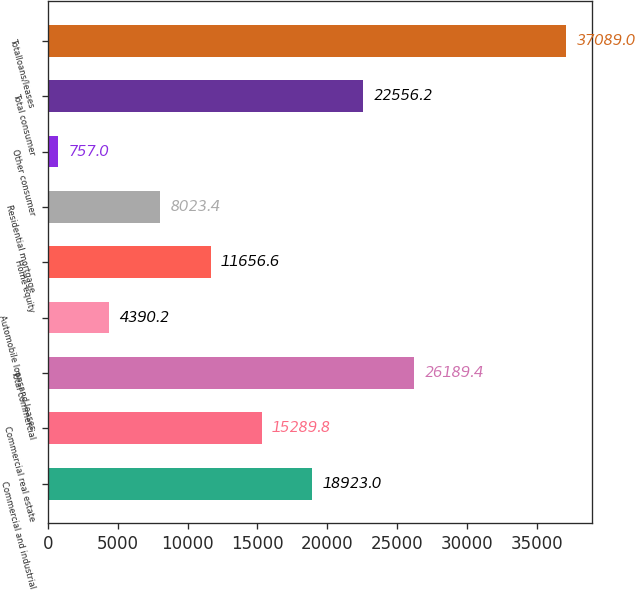Convert chart to OTSL. <chart><loc_0><loc_0><loc_500><loc_500><bar_chart><fcel>Commercial and industrial<fcel>Commercial real estate<fcel>Total commercial<fcel>Automobile loansand leases<fcel>Home equity<fcel>Residential mortgage<fcel>Other consumer<fcel>Total consumer<fcel>Totalloans/leases<nl><fcel>18923<fcel>15289.8<fcel>26189.4<fcel>4390.2<fcel>11656.6<fcel>8023.4<fcel>757<fcel>22556.2<fcel>37089<nl></chart> 